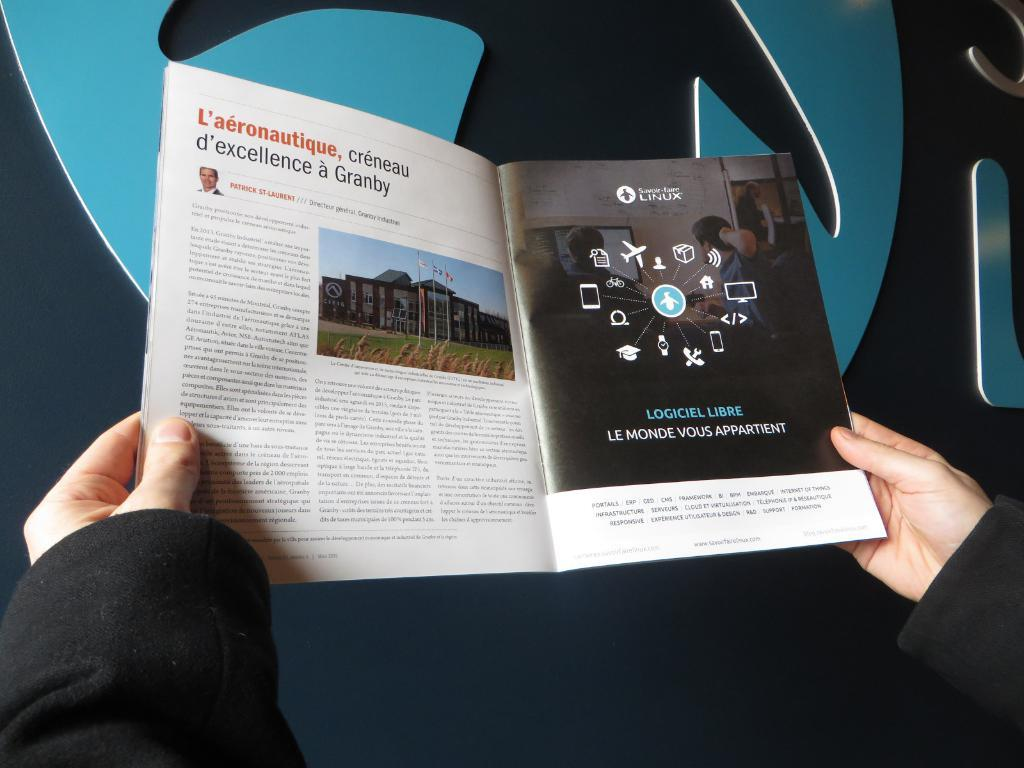<image>
Write a terse but informative summary of the picture. A magazine is open to an ad for Savoir Faire Linux 